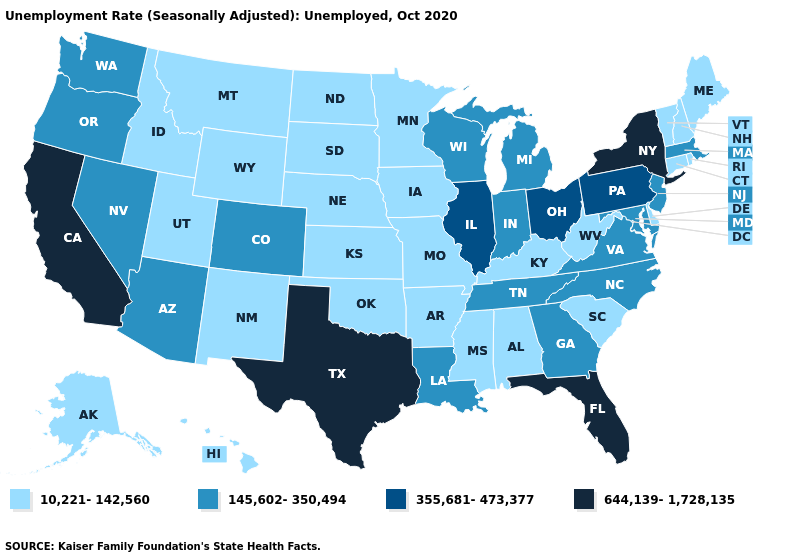What is the highest value in the USA?
Write a very short answer. 644,139-1,728,135. What is the value of Vermont?
Short answer required. 10,221-142,560. Which states hav the highest value in the MidWest?
Give a very brief answer. Illinois, Ohio. Among the states that border Montana , which have the lowest value?
Write a very short answer. Idaho, North Dakota, South Dakota, Wyoming. Name the states that have a value in the range 355,681-473,377?
Be succinct. Illinois, Ohio, Pennsylvania. Which states have the lowest value in the USA?
Short answer required. Alabama, Alaska, Arkansas, Connecticut, Delaware, Hawaii, Idaho, Iowa, Kansas, Kentucky, Maine, Minnesota, Mississippi, Missouri, Montana, Nebraska, New Hampshire, New Mexico, North Dakota, Oklahoma, Rhode Island, South Carolina, South Dakota, Utah, Vermont, West Virginia, Wyoming. Does Massachusetts have the lowest value in the USA?
Short answer required. No. Does the first symbol in the legend represent the smallest category?
Answer briefly. Yes. What is the value of North Dakota?
Be succinct. 10,221-142,560. Does the first symbol in the legend represent the smallest category?
Give a very brief answer. Yes. How many symbols are there in the legend?
Write a very short answer. 4. What is the value of New York?
Concise answer only. 644,139-1,728,135. Does Washington have the same value as Florida?
Give a very brief answer. No. Does the map have missing data?
Quick response, please. No. Among the states that border Rhode Island , which have the lowest value?
Give a very brief answer. Connecticut. 